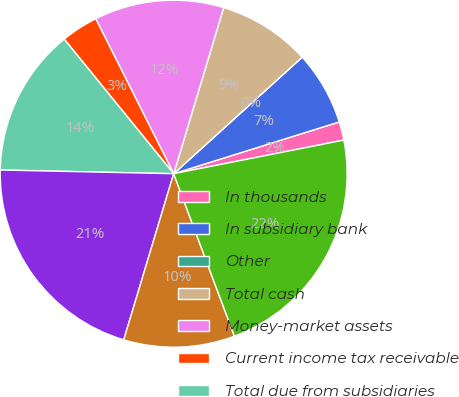Convert chart. <chart><loc_0><loc_0><loc_500><loc_500><pie_chart><fcel>In thousands<fcel>In subsidiary bank<fcel>Other<fcel>Total cash<fcel>Money-market assets<fcel>Current income tax receivable<fcel>Total due from subsidiaries<fcel>Banks and bank holding company<fcel>Other assets<fcel>Total assets<nl><fcel>1.72%<fcel>6.9%<fcel>0.0%<fcel>8.62%<fcel>12.07%<fcel>3.45%<fcel>13.79%<fcel>20.69%<fcel>10.34%<fcel>22.41%<nl></chart> 